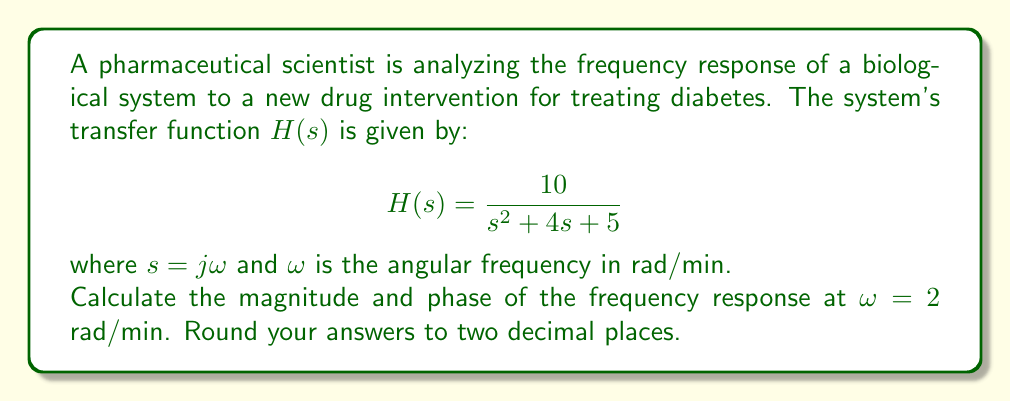Could you help me with this problem? To analyze the frequency response, we need to evaluate the transfer function $H(s)$ at $s = j\omega$:

1) Substitute $s = j\omega$ into $H(s)$:
   $$H(j\omega) = \frac{10}{(j\omega)^2 + 4(j\omega) + 5}$$

2) For $\omega = 2$ rad/min:
   $$H(j2) = \frac{10}{(j2)^2 + 4(j2) + 5}$$

3) Simplify:
   $$H(j2) = \frac{10}{-4 + 8j + 5} = \frac{10}{1 + 8j}$$

4) To find the magnitude and phase, we need to convert this to polar form. Let's separate the real and imaginary parts:
   $$H(j2) = \frac{10}{1 + 8j} = \frac{10(1 - 8j)}{(1 + 8j)(1 - 8j)} = \frac{10 - 80j}{1 + 64} = \frac{10 - 80j}{65}$$

5) The magnitude is given by:
   $$|H(j2)| = \sqrt{\left(\frac{10}{65}\right)^2 + \left(\frac{-80}{65}\right)^2} = \sqrt{\frac{100 + 6400}{4225}} = \frac{\sqrt{6500}}{65} \approx 1.24$$

6) The phase is given by:
   $$\angle H(j2) = \tan^{-1}\left(\frac{-80/65}{10/65}\right) = \tan^{-1}(-8) \approx -1.45 \text{ radians}$$

   To convert to degrees: $-1.45 \text{ radians} \times \frac{180°}{\pi} \approx -82.87°$
Answer: Magnitude: 1.24
Phase: -82.87° 